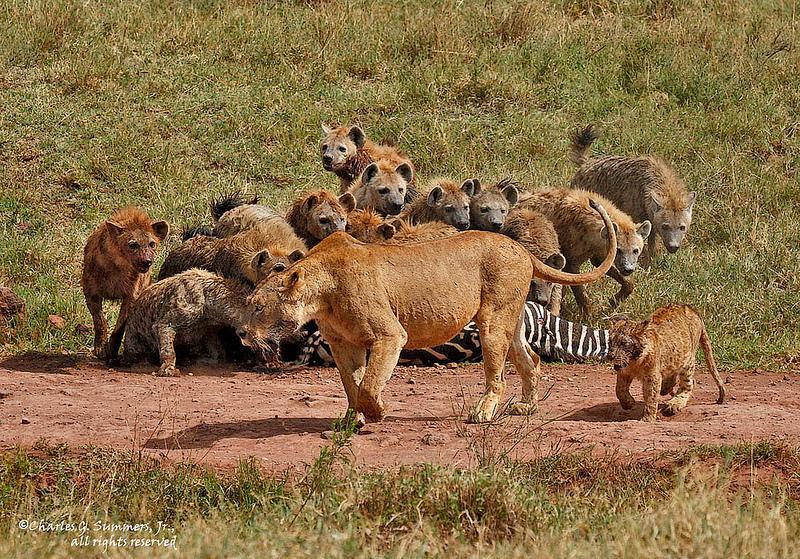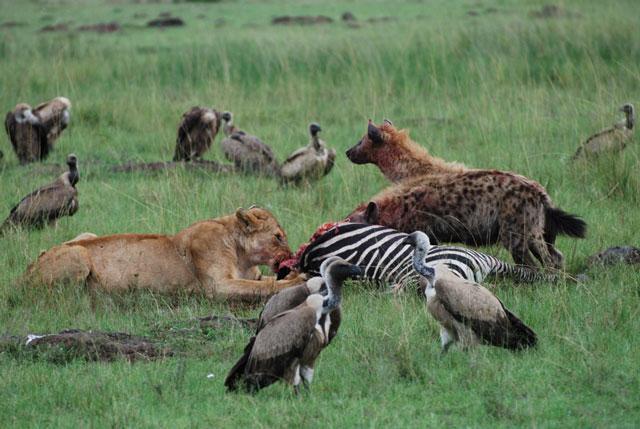The first image is the image on the left, the second image is the image on the right. Assess this claim about the two images: "One of the images contains birds along side the animals.". Correct or not? Answer yes or no. Yes. The first image is the image on the left, the second image is the image on the right. Examine the images to the left and right. Is the description "Left image includes zebra in an image with hyena." accurate? Answer yes or no. Yes. 